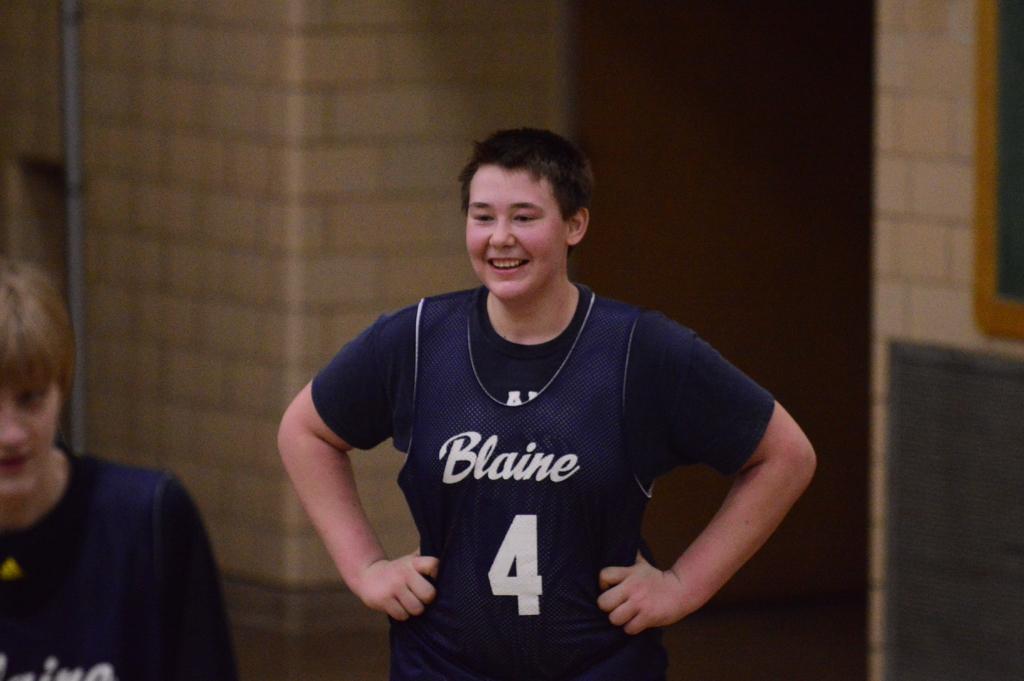What number is he?
Give a very brief answer. 4. What is the name on the jersey?
Provide a short and direct response. Blaine. 